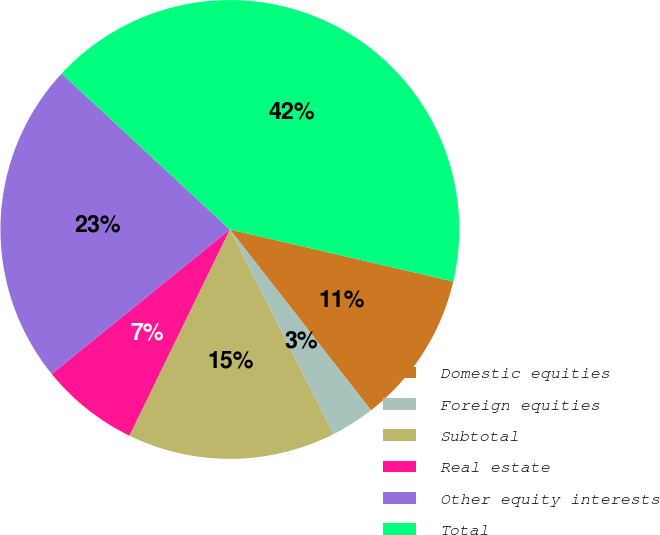<chart> <loc_0><loc_0><loc_500><loc_500><pie_chart><fcel>Domestic equities<fcel>Foreign equities<fcel>Subtotal<fcel>Real estate<fcel>Other equity interests<fcel>Total<nl><fcel>10.81%<fcel>3.08%<fcel>14.68%<fcel>6.94%<fcel>22.74%<fcel>41.75%<nl></chart> 